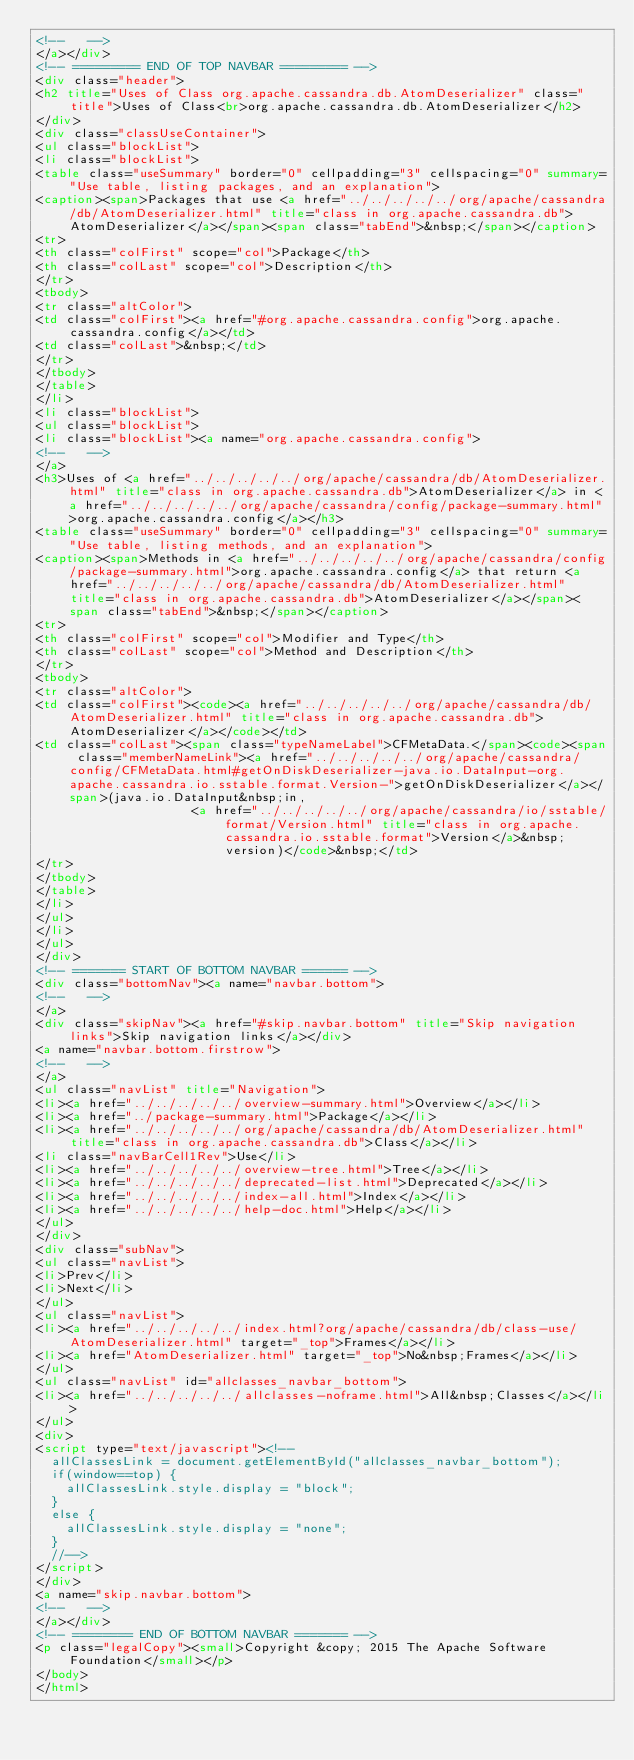<code> <loc_0><loc_0><loc_500><loc_500><_HTML_><!--   -->
</a></div>
<!-- ========= END OF TOP NAVBAR ========= -->
<div class="header">
<h2 title="Uses of Class org.apache.cassandra.db.AtomDeserializer" class="title">Uses of Class<br>org.apache.cassandra.db.AtomDeserializer</h2>
</div>
<div class="classUseContainer">
<ul class="blockList">
<li class="blockList">
<table class="useSummary" border="0" cellpadding="3" cellspacing="0" summary="Use table, listing packages, and an explanation">
<caption><span>Packages that use <a href="../../../../../org/apache/cassandra/db/AtomDeserializer.html" title="class in org.apache.cassandra.db">AtomDeserializer</a></span><span class="tabEnd">&nbsp;</span></caption>
<tr>
<th class="colFirst" scope="col">Package</th>
<th class="colLast" scope="col">Description</th>
</tr>
<tbody>
<tr class="altColor">
<td class="colFirst"><a href="#org.apache.cassandra.config">org.apache.cassandra.config</a></td>
<td class="colLast">&nbsp;</td>
</tr>
</tbody>
</table>
</li>
<li class="blockList">
<ul class="blockList">
<li class="blockList"><a name="org.apache.cassandra.config">
<!--   -->
</a>
<h3>Uses of <a href="../../../../../org/apache/cassandra/db/AtomDeserializer.html" title="class in org.apache.cassandra.db">AtomDeserializer</a> in <a href="../../../../../org/apache/cassandra/config/package-summary.html">org.apache.cassandra.config</a></h3>
<table class="useSummary" border="0" cellpadding="3" cellspacing="0" summary="Use table, listing methods, and an explanation">
<caption><span>Methods in <a href="../../../../../org/apache/cassandra/config/package-summary.html">org.apache.cassandra.config</a> that return <a href="../../../../../org/apache/cassandra/db/AtomDeserializer.html" title="class in org.apache.cassandra.db">AtomDeserializer</a></span><span class="tabEnd">&nbsp;</span></caption>
<tr>
<th class="colFirst" scope="col">Modifier and Type</th>
<th class="colLast" scope="col">Method and Description</th>
</tr>
<tbody>
<tr class="altColor">
<td class="colFirst"><code><a href="../../../../../org/apache/cassandra/db/AtomDeserializer.html" title="class in org.apache.cassandra.db">AtomDeserializer</a></code></td>
<td class="colLast"><span class="typeNameLabel">CFMetaData.</span><code><span class="memberNameLink"><a href="../../../../../org/apache/cassandra/config/CFMetaData.html#getOnDiskDeserializer-java.io.DataInput-org.apache.cassandra.io.sstable.format.Version-">getOnDiskDeserializer</a></span>(java.io.DataInput&nbsp;in,
                     <a href="../../../../../org/apache/cassandra/io/sstable/format/Version.html" title="class in org.apache.cassandra.io.sstable.format">Version</a>&nbsp;version)</code>&nbsp;</td>
</tr>
</tbody>
</table>
</li>
</ul>
</li>
</ul>
</div>
<!-- ======= START OF BOTTOM NAVBAR ====== -->
<div class="bottomNav"><a name="navbar.bottom">
<!--   -->
</a>
<div class="skipNav"><a href="#skip.navbar.bottom" title="Skip navigation links">Skip navigation links</a></div>
<a name="navbar.bottom.firstrow">
<!--   -->
</a>
<ul class="navList" title="Navigation">
<li><a href="../../../../../overview-summary.html">Overview</a></li>
<li><a href="../package-summary.html">Package</a></li>
<li><a href="../../../../../org/apache/cassandra/db/AtomDeserializer.html" title="class in org.apache.cassandra.db">Class</a></li>
<li class="navBarCell1Rev">Use</li>
<li><a href="../../../../../overview-tree.html">Tree</a></li>
<li><a href="../../../../../deprecated-list.html">Deprecated</a></li>
<li><a href="../../../../../index-all.html">Index</a></li>
<li><a href="../../../../../help-doc.html">Help</a></li>
</ul>
</div>
<div class="subNav">
<ul class="navList">
<li>Prev</li>
<li>Next</li>
</ul>
<ul class="navList">
<li><a href="../../../../../index.html?org/apache/cassandra/db/class-use/AtomDeserializer.html" target="_top">Frames</a></li>
<li><a href="AtomDeserializer.html" target="_top">No&nbsp;Frames</a></li>
</ul>
<ul class="navList" id="allclasses_navbar_bottom">
<li><a href="../../../../../allclasses-noframe.html">All&nbsp;Classes</a></li>
</ul>
<div>
<script type="text/javascript"><!--
  allClassesLink = document.getElementById("allclasses_navbar_bottom");
  if(window==top) {
    allClassesLink.style.display = "block";
  }
  else {
    allClassesLink.style.display = "none";
  }
  //-->
</script>
</div>
<a name="skip.navbar.bottom">
<!--   -->
</a></div>
<!-- ======== END OF BOTTOM NAVBAR ======= -->
<p class="legalCopy"><small>Copyright &copy; 2015 The Apache Software Foundation</small></p>
</body>
</html>
</code> 